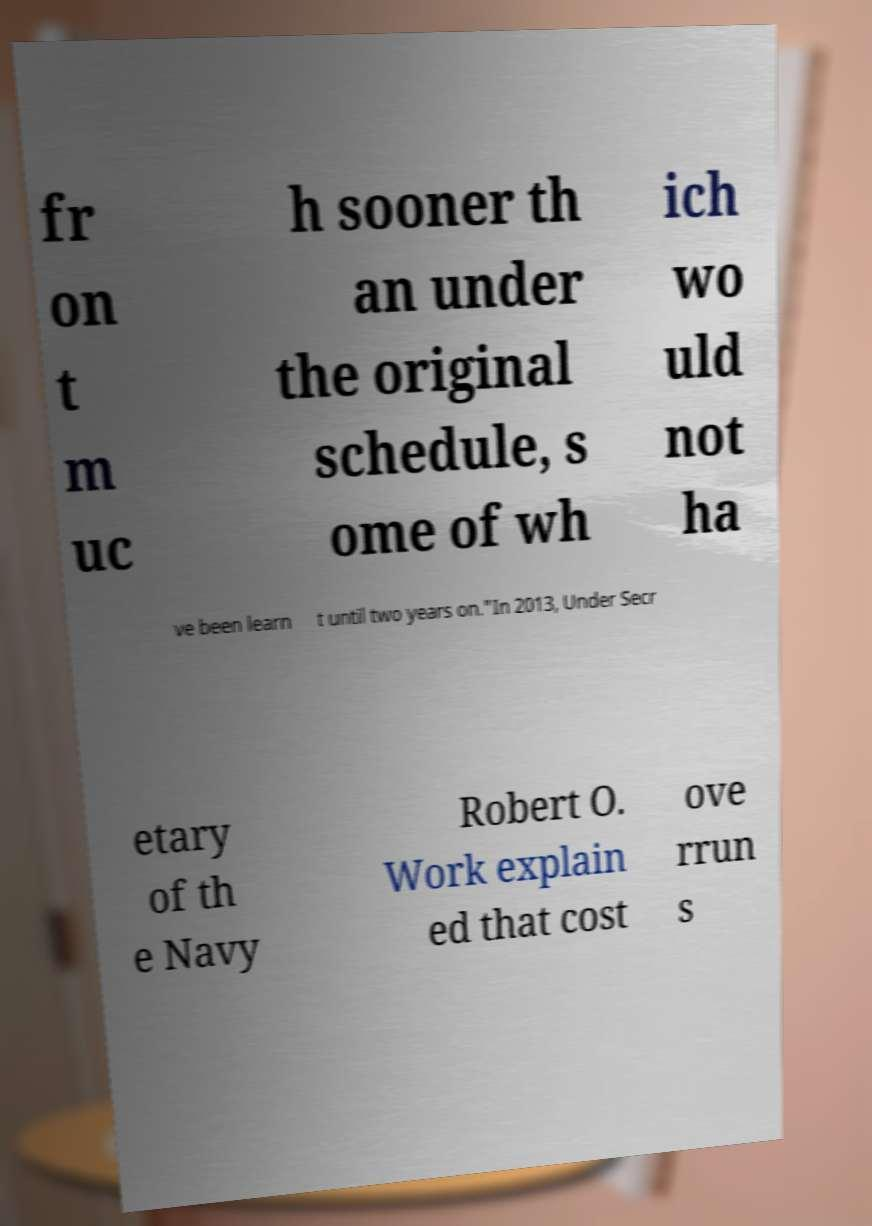What messages or text are displayed in this image? I need them in a readable, typed format. fr on t m uc h sooner th an under the original schedule, s ome of wh ich wo uld not ha ve been learn t until two years on."In 2013, Under Secr etary of th e Navy Robert O. Work explain ed that cost ove rrun s 